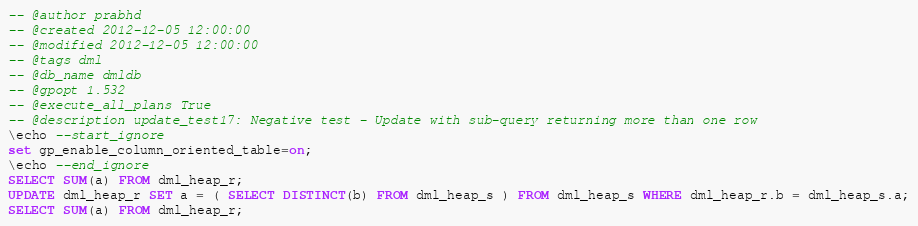<code> <loc_0><loc_0><loc_500><loc_500><_SQL_>-- @author prabhd 
-- @created 2012-12-05 12:00:00 
-- @modified 2012-12-05 12:00:00 
-- @tags dml 
-- @db_name dmldb
-- @gpopt 1.532
-- @execute_all_plans True
-- @description update_test17: Negative test - Update with sub-query returning more than one row
\echo --start_ignore
set gp_enable_column_oriented_table=on;
\echo --end_ignore
SELECT SUM(a) FROM dml_heap_r;
UPDATE dml_heap_r SET a = ( SELECT DISTINCT(b) FROM dml_heap_s ) FROM dml_heap_s WHERE dml_heap_r.b = dml_heap_s.a;
SELECT SUM(a) FROM dml_heap_r;
</code> 